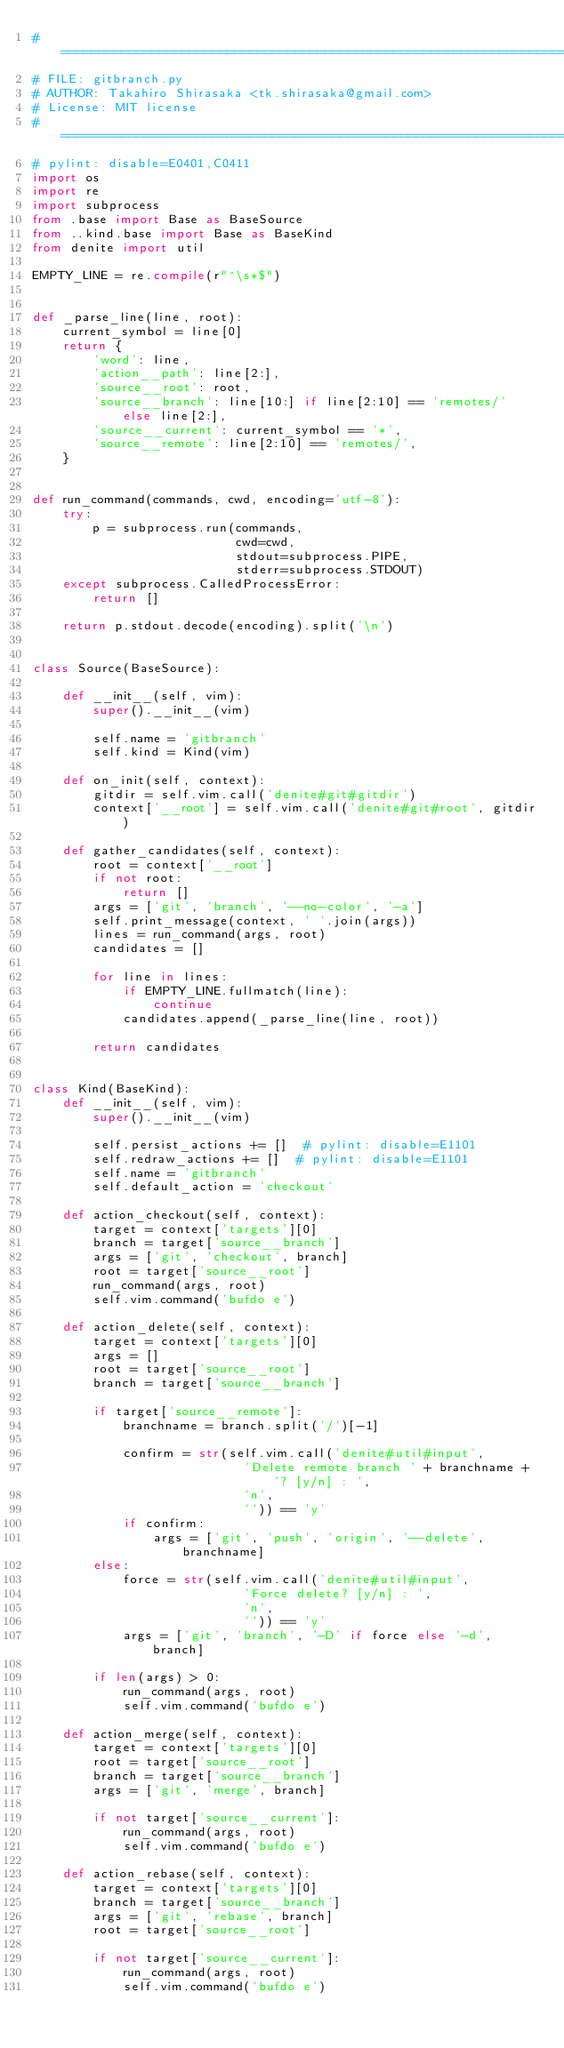Convert code to text. <code><loc_0><loc_0><loc_500><loc_500><_Python_># ============================================================================
# FILE: gitbranch.py
# AUTHOR: Takahiro Shirasaka <tk.shirasaka@gmail.com>
# License: MIT license
# ============================================================================
# pylint: disable=E0401,C0411
import os
import re
import subprocess
from .base import Base as BaseSource
from ..kind.base import Base as BaseKind
from denite import util

EMPTY_LINE = re.compile(r"^\s*$")


def _parse_line(line, root):
    current_symbol = line[0]
    return {
        'word': line,
        'action__path': line[2:],
        'source__root': root,
        'source__branch': line[10:] if line[2:10] == 'remotes/' else line[2:],
        'source__current': current_symbol == '*',
        'source__remote': line[2:10] == 'remotes/',
    }


def run_command(commands, cwd, encoding='utf-8'):
    try:
        p = subprocess.run(commands,
                           cwd=cwd,
                           stdout=subprocess.PIPE,
                           stderr=subprocess.STDOUT)
    except subprocess.CalledProcessError:
        return []

    return p.stdout.decode(encoding).split('\n')


class Source(BaseSource):

    def __init__(self, vim):
        super().__init__(vim)

        self.name = 'gitbranch'
        self.kind = Kind(vim)

    def on_init(self, context):
        gitdir = self.vim.call('denite#git#gitdir')
        context['__root'] = self.vim.call('denite#git#root', gitdir)

    def gather_candidates(self, context):
        root = context['__root']
        if not root:
            return []
        args = ['git', 'branch', '--no-color', '-a']
        self.print_message(context, ' '.join(args))
        lines = run_command(args, root)
        candidates = []

        for line in lines:
            if EMPTY_LINE.fullmatch(line):
                continue
            candidates.append(_parse_line(line, root))

        return candidates


class Kind(BaseKind):
    def __init__(self, vim):
        super().__init__(vim)

        self.persist_actions += []  # pylint: disable=E1101
        self.redraw_actions += []  # pylint: disable=E1101
        self.name = 'gitbranch'
        self.default_action = 'checkout'

    def action_checkout(self, context):
        target = context['targets'][0]
        branch = target['source__branch']
        args = ['git', 'checkout', branch]
        root = target['source__root']
        run_command(args, root)
        self.vim.command('bufdo e')

    def action_delete(self, context):
        target = context['targets'][0]
        args = []
        root = target['source__root']
        branch = target['source__branch']

        if target['source__remote']:
            branchname = branch.split('/')[-1]

            confirm = str(self.vim.call('denite#util#input',
                            'Delete remote branch ' + branchname + '? [y/n] : ',
                            'n',
                            '')) == 'y'
            if confirm:
                args = ['git', 'push', 'origin', '--delete', branchname]
        else:
            force = str(self.vim.call('denite#util#input',
                            'Force delete? [y/n] : ',
                            'n',
                            '')) == 'y'
            args = ['git', 'branch', '-D' if force else '-d', branch]

        if len(args) > 0:
            run_command(args, root)
            self.vim.command('bufdo e')

    def action_merge(self, context):
        target = context['targets'][0]
        root = target['source__root']
        branch = target['source__branch']
        args = ['git', 'merge', branch]

        if not target['source__current']:
            run_command(args, root)
            self.vim.command('bufdo e')

    def action_rebase(self, context):
        target = context['targets'][0]
        branch = target['source__branch']
        args = ['git', 'rebase', branch]
        root = target['source__root']

        if not target['source__current']:
            run_command(args, root)
            self.vim.command('bufdo e')

</code> 